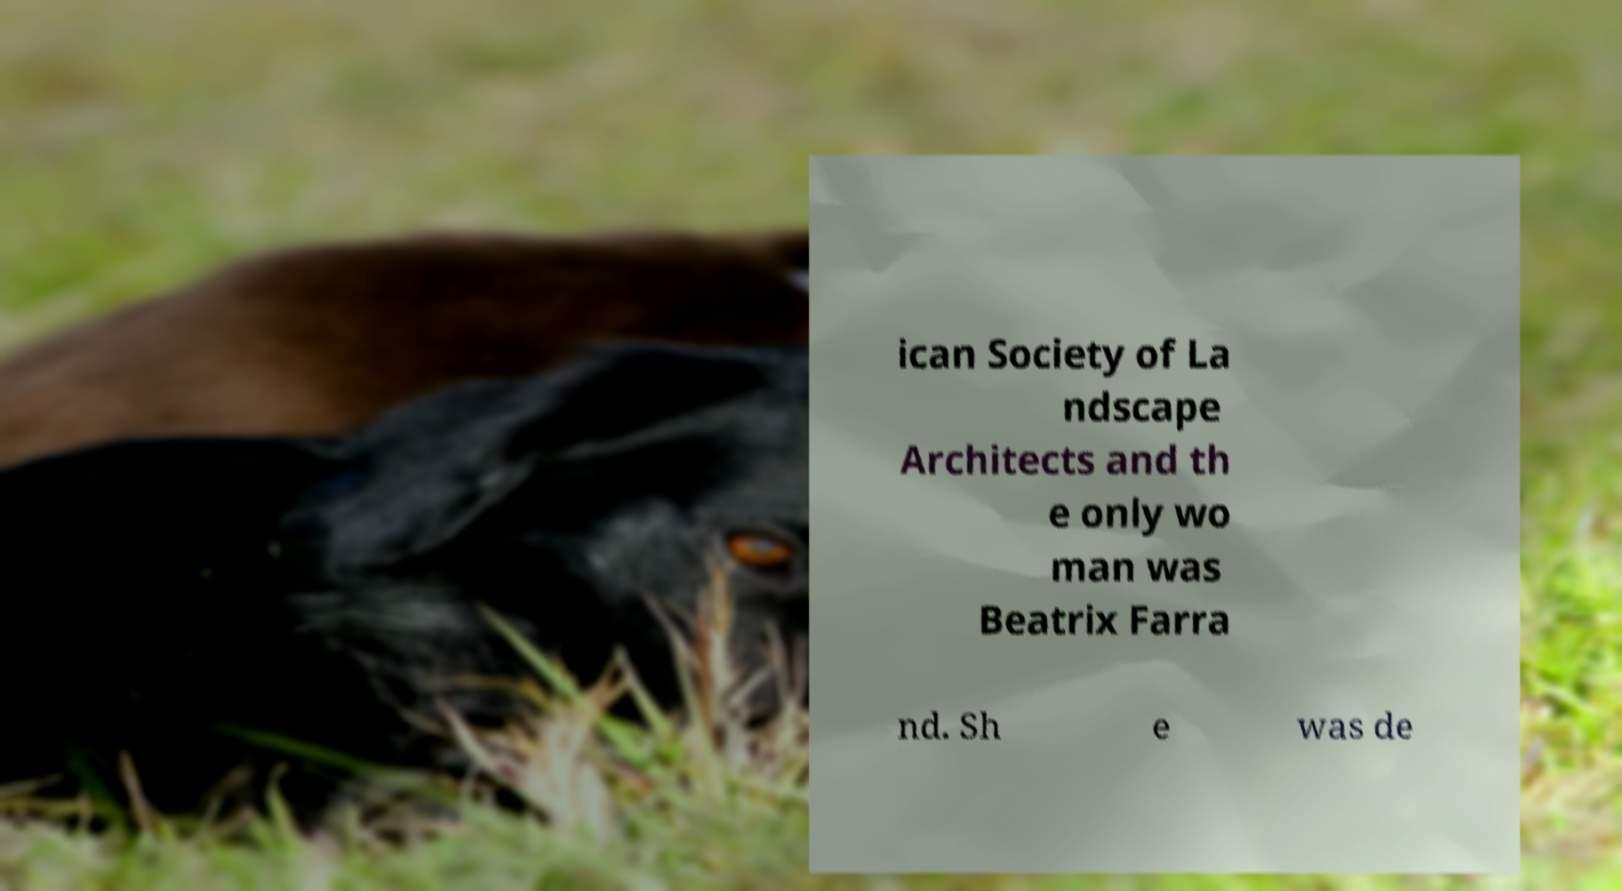What messages or text are displayed in this image? I need them in a readable, typed format. ican Society of La ndscape Architects and th e only wo man was Beatrix Farra nd. Sh e was de 